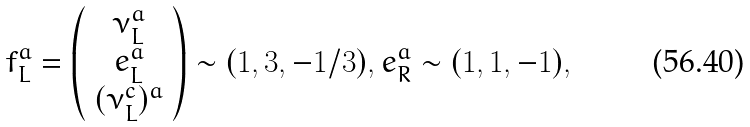Convert formula to latex. <formula><loc_0><loc_0><loc_500><loc_500>f ^ { a } _ { L } = \left ( \begin{array} { c } \nu ^ { a } _ { L } \\ e ^ { a } _ { L } \\ ( \nu ^ { c } _ { L } ) ^ { a } \end{array} \right ) \sim ( 1 , 3 , - 1 / 3 ) , e ^ { a } _ { R } \sim ( 1 , 1 , - 1 ) ,</formula> 